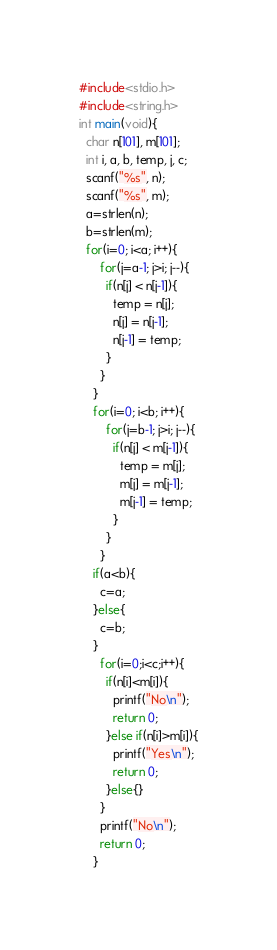<code> <loc_0><loc_0><loc_500><loc_500><_C_>#include<stdio.h>
#include<string.h>
int main(void){
  char n[101], m[101];
  int i, a, b, temp, j, c;
  scanf("%s", n);
  scanf("%s", m);
  a=strlen(n);
  b=strlen(m);
  for(i=0; i<a; i++){
      for(j=a-1; j>i; j--){
        if(n[j] < n[j-1]){
          temp = n[j];
          n[j] = n[j-1];
          n[j-1] = temp;
        }
      }
    }
    for(i=0; i<b; i++){
        for(j=b-1; j>i; j--){
          if(n[j] < m[j-1]){
            temp = m[j];
            m[j] = m[j-1];
            m[j-1] = temp;
          }
        }
      }
    if(a<b){
      c=a;
    }else{
      c=b;
    }
      for(i=0;i<c;i++){
        if(n[i]<m[i]){
          printf("No\n");
          return 0;
        }else if(n[i]>m[i]){
          printf("Yes\n");
          return 0;
        }else{}
      }
      printf("No\n");
      return 0;
    }
</code> 